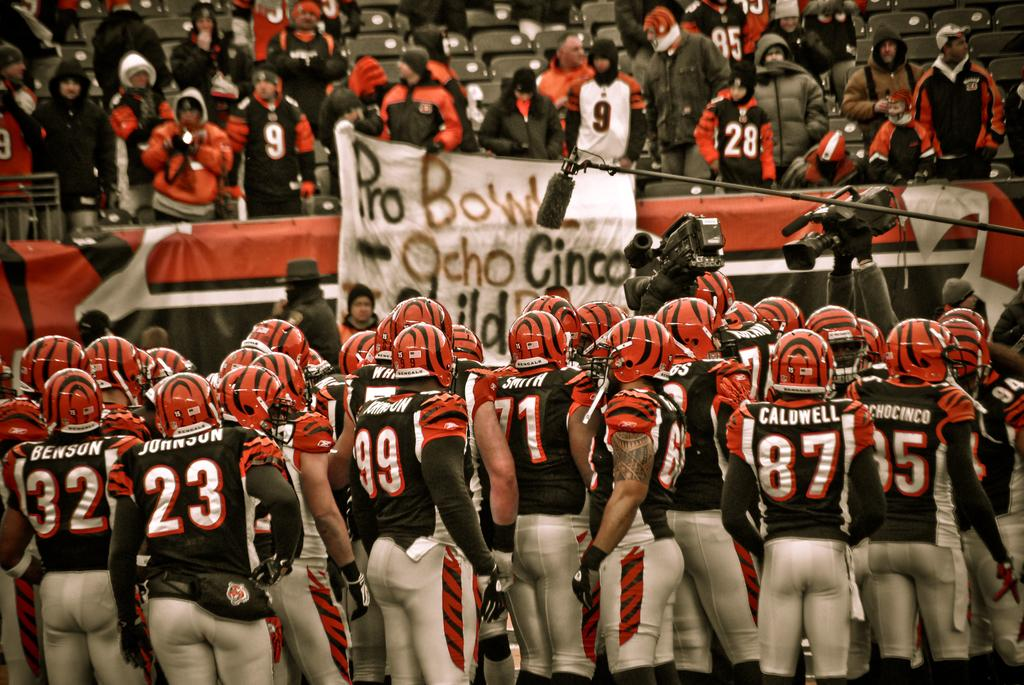Who or what can be seen in the image? There are people in the image. What objects are associated with the people in the image? Cameras and microphones are visible in the image. What are the people wearing in the image? The people are wearing helmets. What can be seen in the background of the image? The background of the image includes people, chairs, and hoardings. Can you describe any specific detail about one of the people in the image? There is a tattoo on one person's hand. What type of butter can be seen melting on the hoardings in the image? There is no butter present in the image; it features people with cameras, microphones, and helmets, along with chairs and hoardings in the background. 